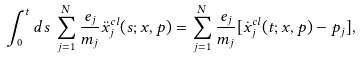<formula> <loc_0><loc_0><loc_500><loc_500>\int _ { 0 } ^ { t } d s \, \sum _ { j = 1 } ^ { N } \frac { e _ { j } } { m _ { j } } \ddot { x } _ { j } ^ { c l } ( s ; x , p ) = \sum _ { j = 1 } ^ { N } \frac { e _ { j } } { m _ { j } } [ \dot { x } _ { j } ^ { c l } ( t ; x , p ) - p _ { j } ] ,</formula> 